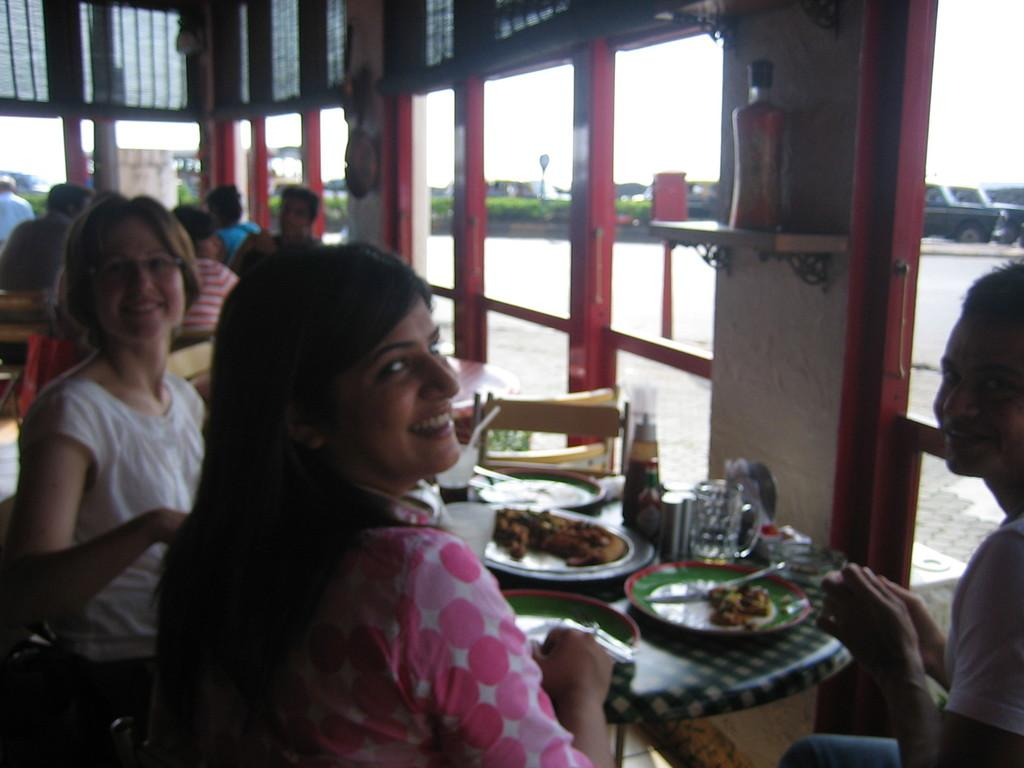What are the people in the image doing? The people in the image are sitting on chairs. What is present on the table in the image? There is a table in the image, and on it, there are plates with food and a glass. What might the people be using the plates for? The plates with food on the table suggest that the people are eating or preparing to eat. What role does the father play in the image? There is no mention of a father or any specific roles in the image. The image only shows people sitting on chairs and a table with plates and a glass. 